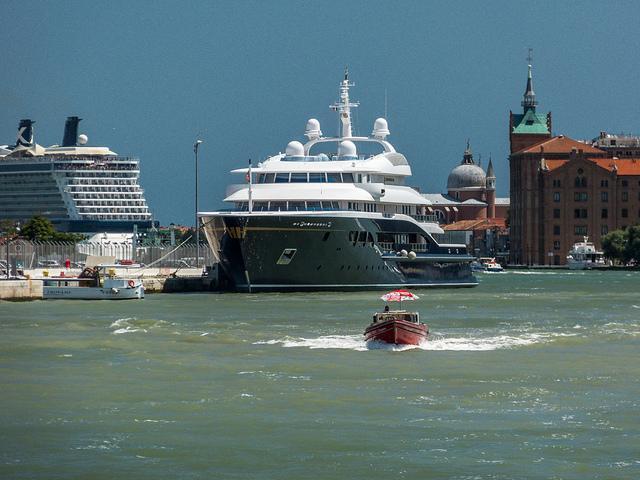Which direction is the large gray ship going?
Make your selection from the four choices given to correctly answer the question.
Options: South, no where, east, north. No where. 